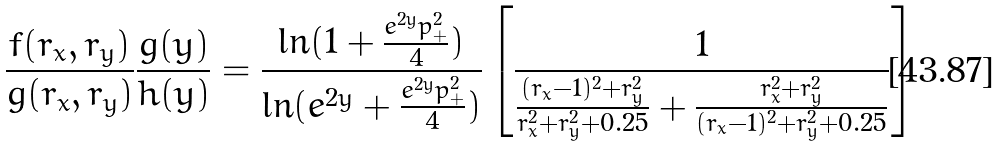Convert formula to latex. <formula><loc_0><loc_0><loc_500><loc_500>\frac { f ( r _ { x } , r _ { y } ) } { g ( r _ { x } , r _ { y } ) } \frac { g ( y ) } { h ( y ) } = \frac { \ln ( 1 + \frac { e ^ { 2 y } p _ { + } ^ { 2 } } { 4 } ) } { \ln ( e ^ { 2 y } + \frac { e ^ { 2 y } p _ { + } ^ { 2 } } { 4 } ) } \left [ \frac { 1 } { \frac { ( r _ { x } - 1 ) ^ { 2 } + r _ { y } ^ { 2 } } { r _ { x } ^ { 2 } + r _ { y } ^ { 2 } + 0 . 2 5 } + \frac { r _ { x } ^ { 2 } + r _ { y } ^ { 2 } } { ( r _ { x } - 1 ) ^ { 2 } + r _ { y } ^ { 2 } + 0 . 2 5 } } \right ]</formula> 